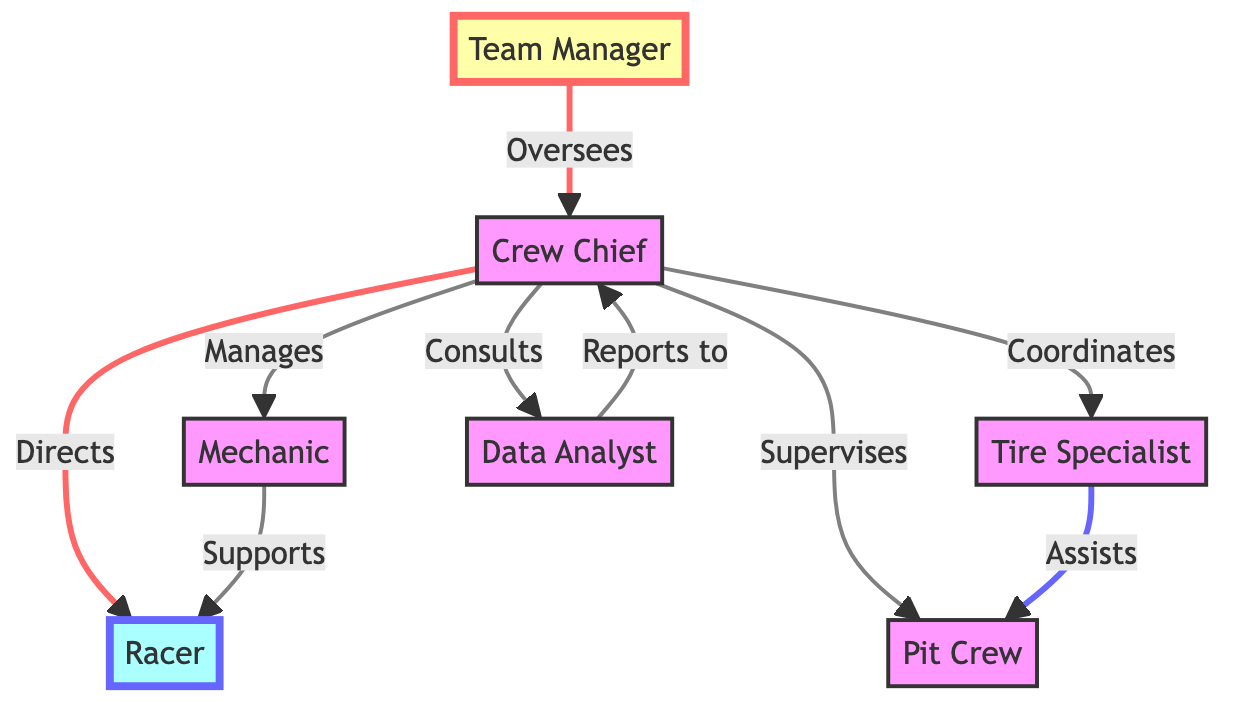What is the role that directly oversees the Crew Chief? The diagram shows an arrow from the Team Manager to the Crew Chief, indicating that the Team Manager is responsible for overseeing the Crew Chief’s role.
Answer: Team Manager How many roles are responsible for the Racer's performance? In the diagram, there are two nodes that are linked to the Racer: the Crew Chief and the Mechanic, showing they both have a direct responsibility towards the Racer.
Answer: Two Which role reports to the Crew Chief? The diagram shows an arrow from the Data Analyst to the Crew Chief, indicating that the Data Analyst is the role that reports directly to the Crew Chief.
Answer: Data Analyst Which team member assists the Pit Crew? The arrow from the Tire Specialist to the Pit Crew indicates that the Tire Specialist is the team member who assists the Pit Crew during race day.
Answer: Tire Specialist What is the relationship between the Crew Chief and the Racer? The diagram shows a directional link indicating that the Crew Chief directs the Racer, which establishes a guidance or leadership relationship.
Answer: Directs How many total roles are represented in the diagram? By counting all the distinct nodes (Team Manager, Crew Chief, Racer, Mechanic, Tire Specialist, Data Analyst, Pit Crew), we find there are seven different roles represented in the diagram.
Answer: Seven Who manages the Tire Specialist? The arrow originating from the Crew Chief to the Tire Specialist signifies that the Crew Chief has a managing role over the Tire Specialist.
Answer: Crew Chief What is the flow of tasks from the Team Manager to the Racer? The flow begins with the Team Manager overseeing the Crew Chief, who then directs the Racer. This indicates a hierarchical structure of task delegation leading to the Racer.
Answer: Team Manager → Crew Chief → Racer Which role connects the Mechanic and the Racer? The edge from Mechanic to Racer signifies that the Mechanic supports the Racer; hence, the Mechanic is the connecting role in this flow.
Answer: Mechanic 